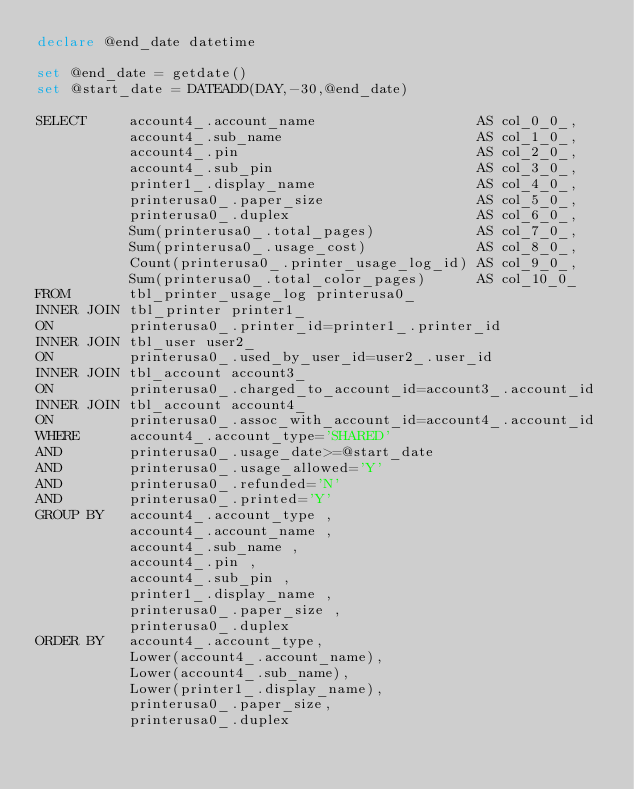Convert code to text. <code><loc_0><loc_0><loc_500><loc_500><_SQL_>declare @end_date datetime

set @end_date = getdate()
set @start_date = DATEADD(DAY,-30,@end_date)

SELECT     account4_.account_name                   AS col_0_0_, 
           account4_.sub_name                       AS col_1_0_, 
           account4_.pin                            AS col_2_0_, 
           account4_.sub_pin                        AS col_3_0_, 
           printer1_.display_name                   AS col_4_0_, 
           printerusa0_.paper_size                  AS col_5_0_, 
           printerusa0_.duplex                      AS col_6_0_, 
           Sum(printerusa0_.total_pages)            AS col_7_0_, 
           Sum(printerusa0_.usage_cost)             AS col_8_0_, 
           Count(printerusa0_.printer_usage_log_id) AS col_9_0_, 
           Sum(printerusa0_.total_color_pages)      AS col_10_0_ 
FROM       tbl_printer_usage_log printerusa0_ 
INNER JOIN tbl_printer printer1_ 
ON         printerusa0_.printer_id=printer1_.printer_id 
INNER JOIN tbl_user user2_ 
ON         printerusa0_.used_by_user_id=user2_.user_id 
INNER JOIN tbl_account account3_ 
ON         printerusa0_.charged_to_account_id=account3_.account_id 
INNER JOIN tbl_account account4_ 
ON         printerusa0_.assoc_with_account_id=account4_.account_id 
WHERE      account4_.account_type='SHARED' 
AND        printerusa0_.usage_date>=@start_date 
AND        printerusa0_.usage_allowed='Y'
AND        printerusa0_.refunded='N' 
AND        printerusa0_.printed='Y' 
GROUP BY   account4_.account_type , 
           account4_.account_name , 
           account4_.sub_name , 
           account4_.pin , 
           account4_.sub_pin , 
           printer1_.display_name , 
           printerusa0_.paper_size , 
           printerusa0_.duplex 
ORDER BY   account4_.account_type, 
           Lower(account4_.account_name), 
           Lower(account4_.sub_name), 
           Lower(printer1_.display_name), 
           printerusa0_.paper_size, 
           printerusa0_.duplex</code> 